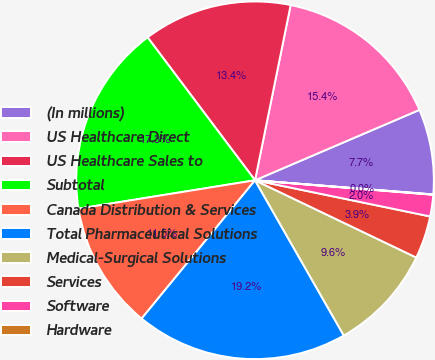Convert chart to OTSL. <chart><loc_0><loc_0><loc_500><loc_500><pie_chart><fcel>(In millions)<fcel>US Healthcare Direct<fcel>US Healthcare Sales to<fcel>Subtotal<fcel>Canada Distribution & Services<fcel>Total Pharmaceutical Solutions<fcel>Medical-Surgical Solutions<fcel>Services<fcel>Software<fcel>Hardware<nl><fcel>7.7%<fcel>15.37%<fcel>13.45%<fcel>17.28%<fcel>11.53%<fcel>19.2%<fcel>9.62%<fcel>3.87%<fcel>1.95%<fcel>0.03%<nl></chart> 